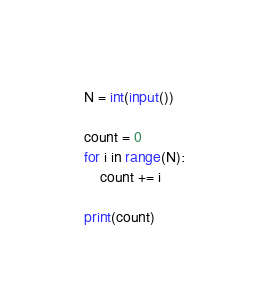Convert code to text. <code><loc_0><loc_0><loc_500><loc_500><_Python_>N = int(input())

count = 0
for i in range(N):
    count += i
    
print(count)
</code> 